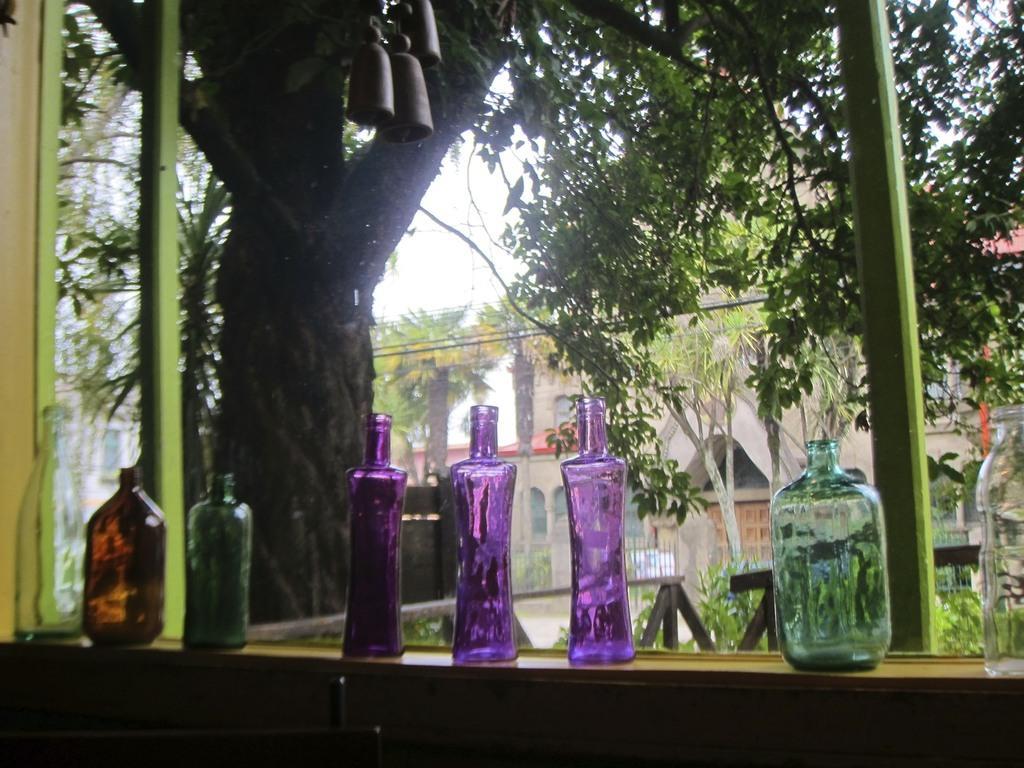Describe this image in one or two sentences. Here are one two three four five six seven eight eight bottles which are made up of glass and all are placed on a table. Behind that, we see benches in the garden and we find trees. On background we see a house with red color, we even see wires and sky. 